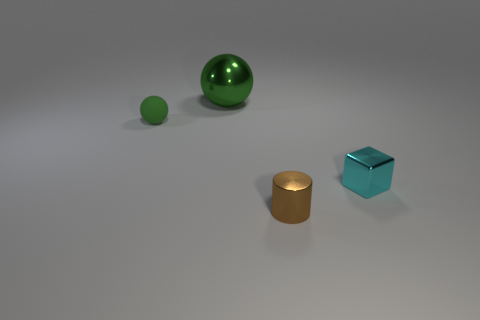There is a green thing that is behind the rubber thing; is it the same shape as the green thing in front of the green metal sphere?
Ensure brevity in your answer.  Yes. There is a brown metallic cylinder; is its size the same as the green sphere that is in front of the green metallic sphere?
Your answer should be compact. Yes. How many other objects are there of the same material as the small cyan cube?
Keep it short and to the point. 2. Is there any other thing that is the same shape as the tiny cyan shiny thing?
Ensure brevity in your answer.  No. There is a object behind the green thing on the left side of the sphere that is behind the tiny green thing; what color is it?
Your answer should be compact. Green. What shape is the small object that is both to the right of the tiny green matte object and behind the brown cylinder?
Your response must be concise. Cube. Is there any other thing that has the same size as the green matte thing?
Offer a terse response. Yes. What is the color of the tiny thing that is to the left of the metal thing behind the small cyan metallic object?
Your answer should be very brief. Green. What shape is the green thing that is to the right of the green ball left of the green thing that is behind the tiny ball?
Your answer should be compact. Sphere. How big is the thing that is both to the right of the green matte thing and on the left side of the small shiny cylinder?
Offer a very short reply. Large. 